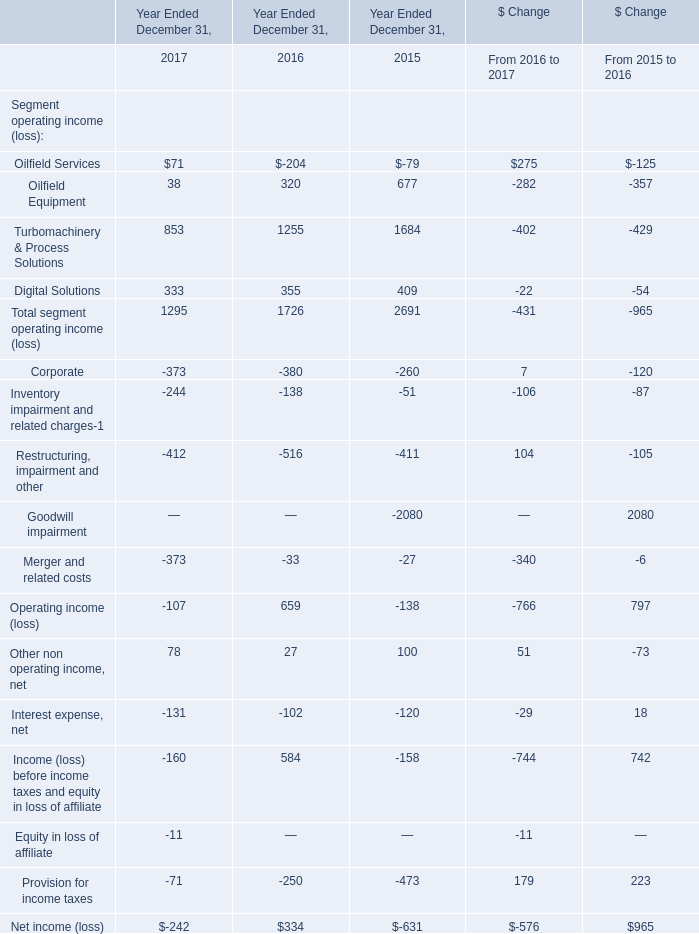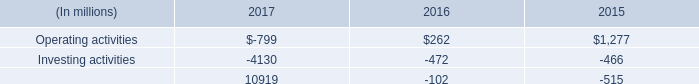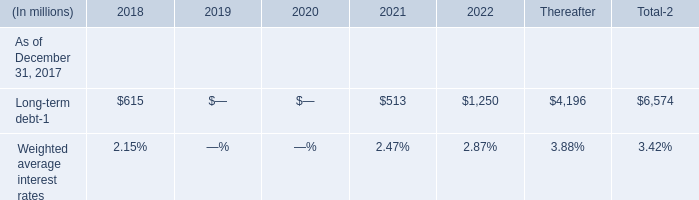what is the net change in cash during 2016? 
Computations: ((262 + -472) + -102)
Answer: -312.0. 